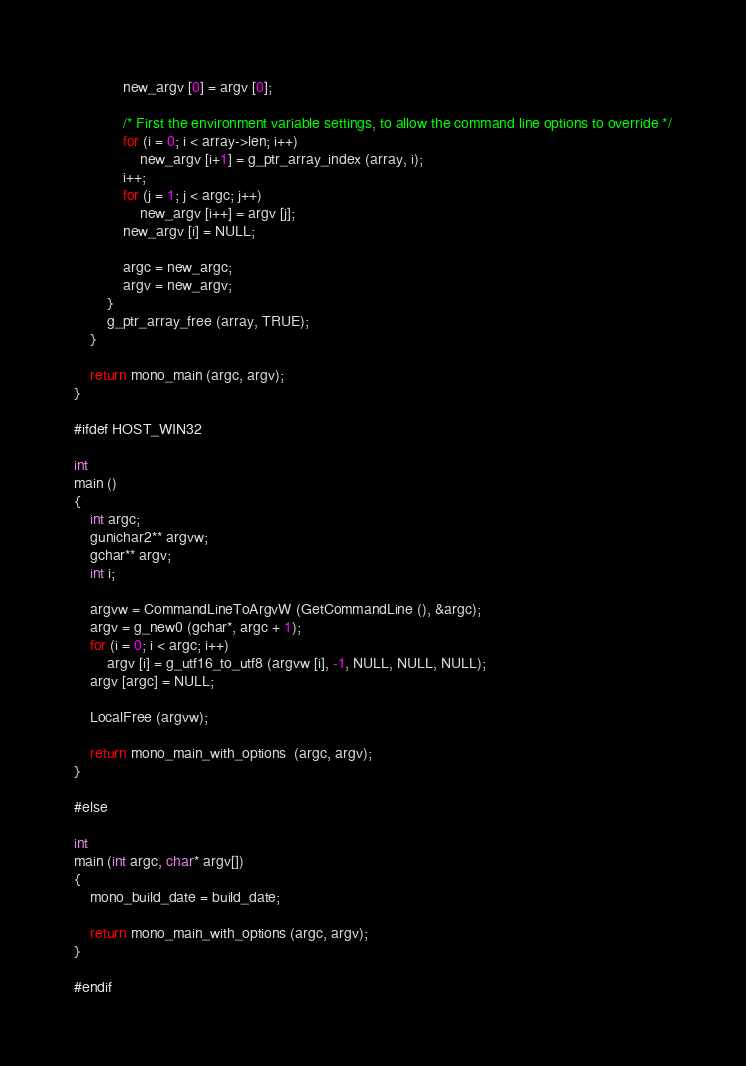Convert code to text. <code><loc_0><loc_0><loc_500><loc_500><_C_>
			new_argv [0] = argv [0];
			
			/* First the environment variable settings, to allow the command line options to override */
			for (i = 0; i < array->len; i++)
				new_argv [i+1] = g_ptr_array_index (array, i);
			i++;
			for (j = 1; j < argc; j++)
				new_argv [i++] = argv [j];
			new_argv [i] = NULL;

			argc = new_argc;
			argv = new_argv;
		}
		g_ptr_array_free (array, TRUE);
	}

	return mono_main (argc, argv);
}

#ifdef HOST_WIN32

int
main ()
{
	int argc;
	gunichar2** argvw;
	gchar** argv;
	int i;

	argvw = CommandLineToArgvW (GetCommandLine (), &argc);
	argv = g_new0 (gchar*, argc + 1);
	for (i = 0; i < argc; i++)
		argv [i] = g_utf16_to_utf8 (argvw [i], -1, NULL, NULL, NULL);
	argv [argc] = NULL;

	LocalFree (argvw);

	return mono_main_with_options  (argc, argv);
}

#else

int
main (int argc, char* argv[])
{
	mono_build_date = build_date;
	
	return mono_main_with_options (argc, argv);
}

#endif
</code> 